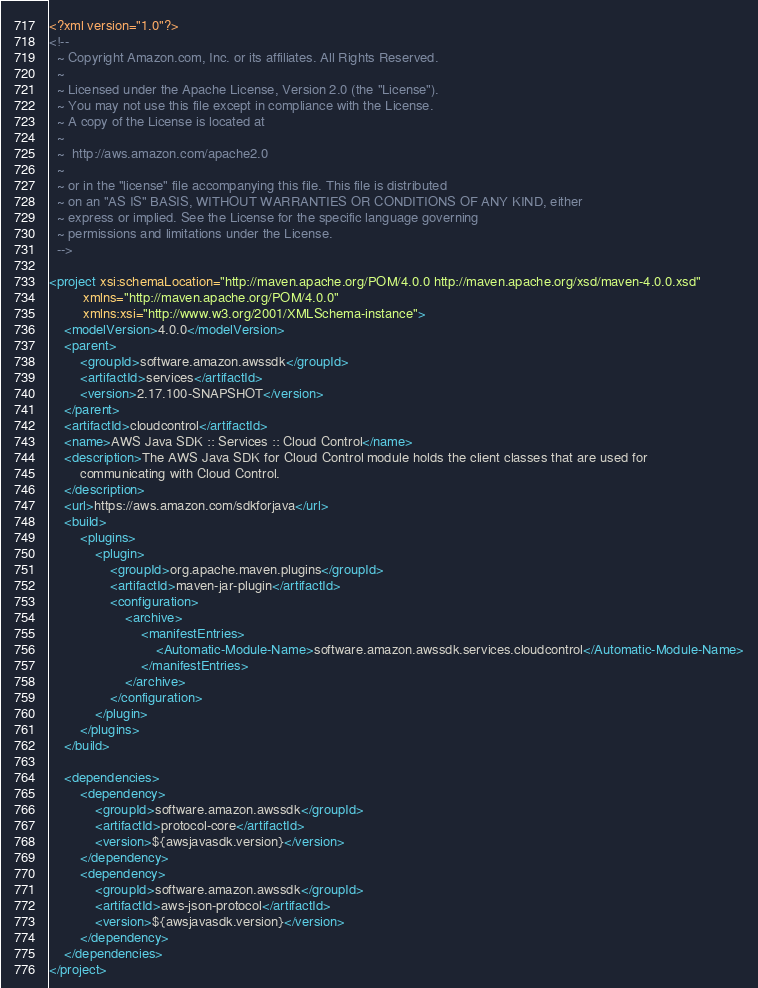Convert code to text. <code><loc_0><loc_0><loc_500><loc_500><_XML_><?xml version="1.0"?>
<!--
  ~ Copyright Amazon.com, Inc. or its affiliates. All Rights Reserved.
  ~
  ~ Licensed under the Apache License, Version 2.0 (the "License").
  ~ You may not use this file except in compliance with the License.
  ~ A copy of the License is located at
  ~
  ~  http://aws.amazon.com/apache2.0
  ~
  ~ or in the "license" file accompanying this file. This file is distributed
  ~ on an "AS IS" BASIS, WITHOUT WARRANTIES OR CONDITIONS OF ANY KIND, either
  ~ express or implied. See the License for the specific language governing
  ~ permissions and limitations under the License.
  -->

<project xsi:schemaLocation="http://maven.apache.org/POM/4.0.0 http://maven.apache.org/xsd/maven-4.0.0.xsd"
         xmlns="http://maven.apache.org/POM/4.0.0"
         xmlns:xsi="http://www.w3.org/2001/XMLSchema-instance">
    <modelVersion>4.0.0</modelVersion>
    <parent>
        <groupId>software.amazon.awssdk</groupId>
        <artifactId>services</artifactId>
        <version>2.17.100-SNAPSHOT</version>
    </parent>
    <artifactId>cloudcontrol</artifactId>
    <name>AWS Java SDK :: Services :: Cloud Control</name>
    <description>The AWS Java SDK for Cloud Control module holds the client classes that are used for
        communicating with Cloud Control.
    </description>
    <url>https://aws.amazon.com/sdkforjava</url>
    <build>
        <plugins>
            <plugin>
                <groupId>org.apache.maven.plugins</groupId>
                <artifactId>maven-jar-plugin</artifactId>
                <configuration>
                    <archive>
                        <manifestEntries>
                            <Automatic-Module-Name>software.amazon.awssdk.services.cloudcontrol</Automatic-Module-Name>
                        </manifestEntries>
                    </archive>
                </configuration>
            </plugin>
        </plugins>
    </build>

    <dependencies>
        <dependency>
            <groupId>software.amazon.awssdk</groupId>
            <artifactId>protocol-core</artifactId>
            <version>${awsjavasdk.version}</version>
        </dependency>
        <dependency>
            <groupId>software.amazon.awssdk</groupId>
            <artifactId>aws-json-protocol</artifactId>
            <version>${awsjavasdk.version}</version>
        </dependency>
    </dependencies>
</project>
</code> 